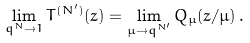Convert formula to latex. <formula><loc_0><loc_0><loc_500><loc_500>\lim _ { q ^ { N } \rightarrow 1 } T ^ { ( N ^ { \prime } ) } ( z ) = \lim _ { \mu \rightarrow q ^ { N ^ { \prime } } } Q _ { \mu } ( z / \mu ) \, .</formula> 